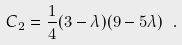Convert formula to latex. <formula><loc_0><loc_0><loc_500><loc_500>C _ { 2 } = \frac { 1 } { 4 } ( 3 - \lambda ) ( 9 - 5 \lambda ) \ .</formula> 